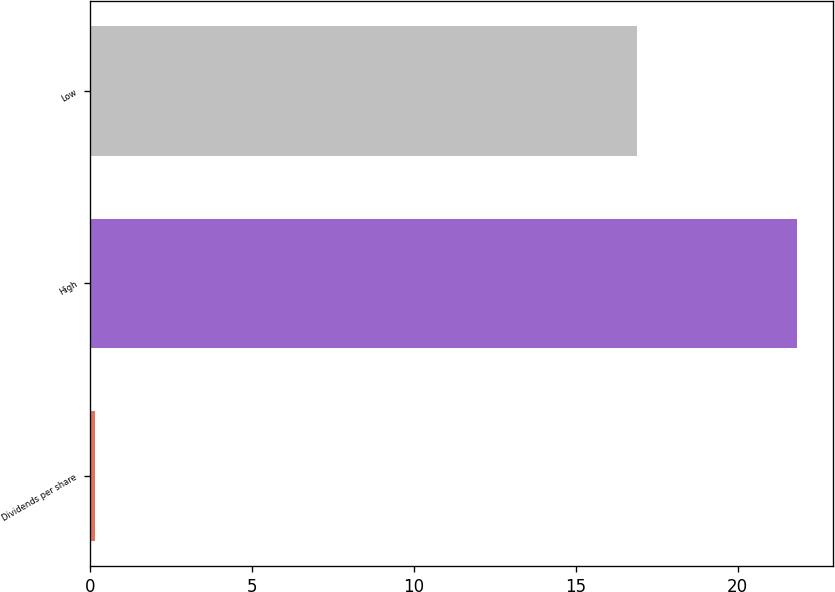Convert chart to OTSL. <chart><loc_0><loc_0><loc_500><loc_500><bar_chart><fcel>Dividends per share<fcel>High<fcel>Low<nl><fcel>0.14<fcel>21.84<fcel>16.89<nl></chart> 